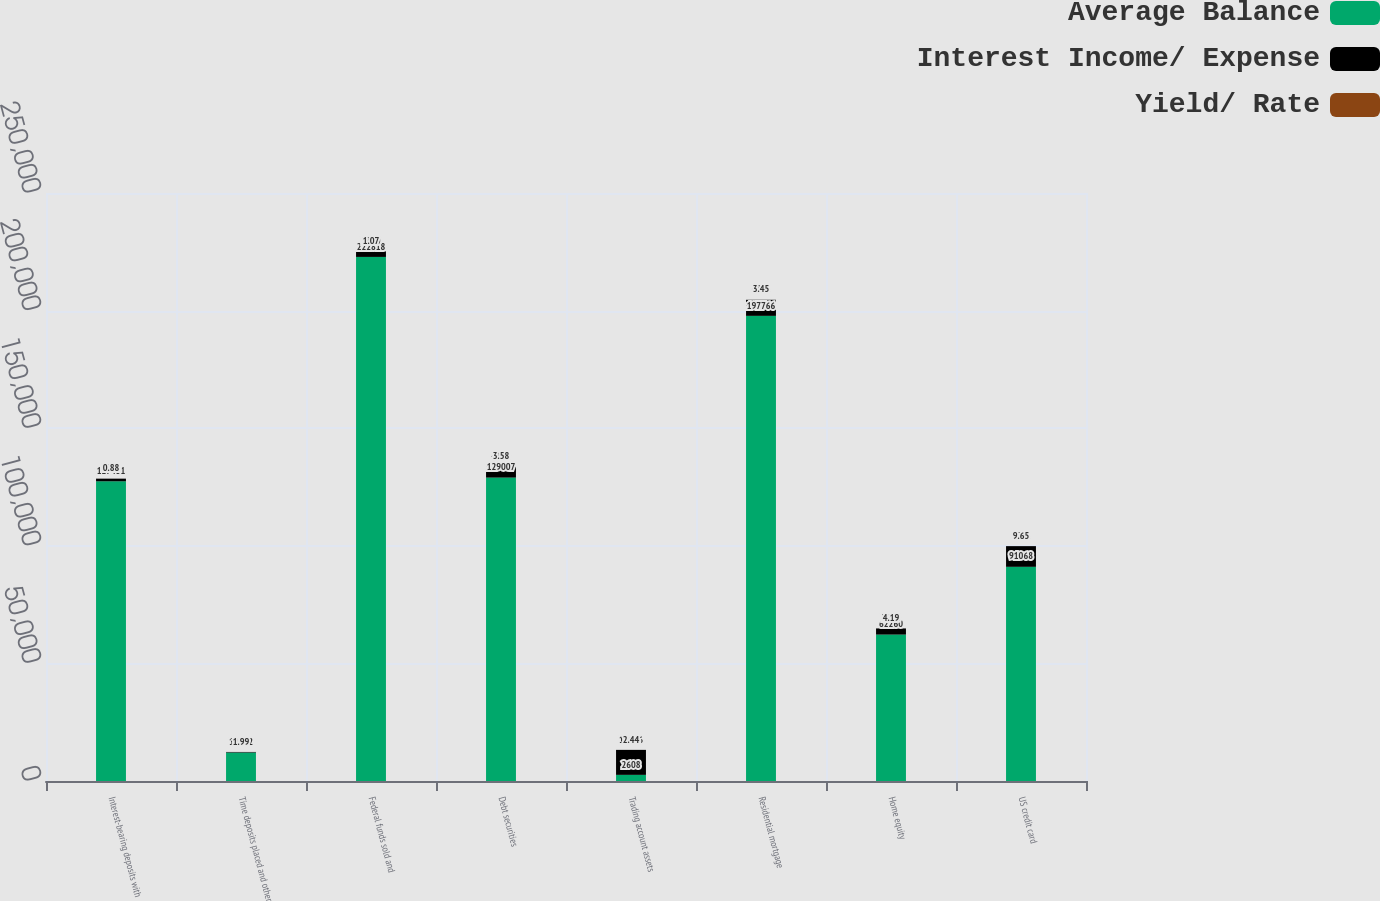<chart> <loc_0><loc_0><loc_500><loc_500><stacked_bar_chart><ecel><fcel>Interest-bearing deposits with<fcel>Time deposits placed and other<fcel>Federal funds sold and<fcel>Debt securities<fcel>Trading account assets<fcel>Residential mortgage<fcel>Home equity<fcel>US credit card<nl><fcel>Average Balance<fcel>127431<fcel>12112<fcel>222818<fcel>129007<fcel>2608<fcel>197766<fcel>62260<fcel>91068<nl><fcel>Interest Income/ Expense<fcel>1122<fcel>241<fcel>2390<fcel>4618<fcel>10626<fcel>6831<fcel>2608<fcel>8791<nl><fcel>Yield/ Rate<fcel>0.88<fcel>1.99<fcel>1.07<fcel>3.58<fcel>2.44<fcel>3.45<fcel>4.19<fcel>9.65<nl></chart> 